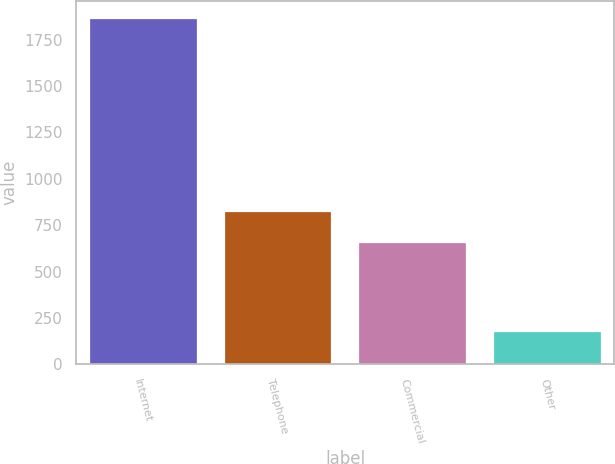Convert chart to OTSL. <chart><loc_0><loc_0><loc_500><loc_500><bar_chart><fcel>Internet<fcel>Telephone<fcel>Commercial<fcel>Other<nl><fcel>1866<fcel>828<fcel>658<fcel>179<nl></chart> 